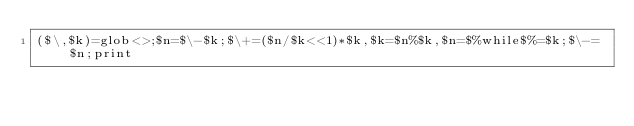Convert code to text. <code><loc_0><loc_0><loc_500><loc_500><_Perl_>($\,$k)=glob<>;$n=$\-$k;$\+=($n/$k<<1)*$k,$k=$n%$k,$n=$%while$%=$k;$\-=$n;print</code> 